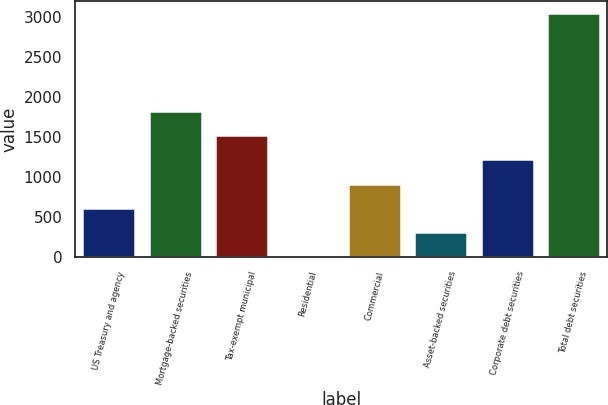<chart> <loc_0><loc_0><loc_500><loc_500><bar_chart><fcel>US Treasury and agency<fcel>Mortgage-backed securities<fcel>Tax-exempt municipal<fcel>Residential<fcel>Commercial<fcel>Asset-backed securities<fcel>Corporate debt securities<fcel>Total debt securities<nl><fcel>614.8<fcel>1830.4<fcel>1526.5<fcel>7<fcel>918.7<fcel>310.9<fcel>1222.6<fcel>3046<nl></chart> 